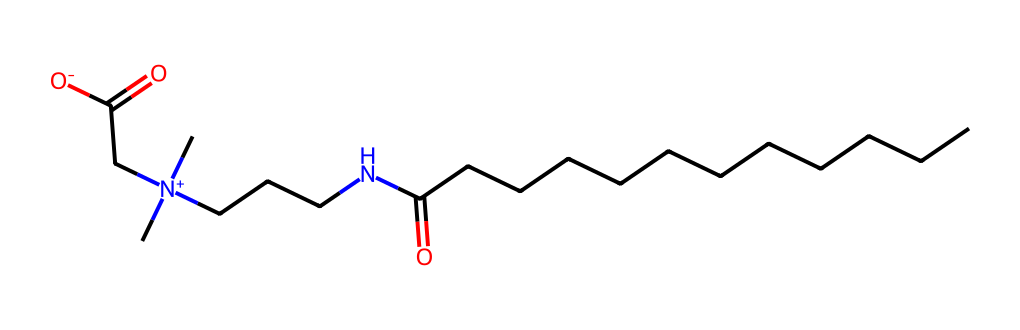What is the name of this chemical? The chemical structure given has characteristics of a surfactant, specifically surfactants derived from fatty acids. The structure indicates the presence of a cocamidopropyl group, which is derived from coconut oil, leading to the name cocamidopropyl betaine.
Answer: cocamidopropyl betaine How many carbon atoms are in this molecule? The SMILES representation shows a long carbon chain along with several branches. By counting the carbon atoms in the structure, there are a total of 12 carbon atoms connected in the chain and branches.
Answer: 12 What type of functional groups are present in this molecule? The molecule includes an amine group (due to the nitrogen atom) and a carboxylic acid group (indicated by the -COOH at the end of the structure). Thus, it contains both an amine and a carboxylic acid as part of its functional groups.
Answer: amine and carboxylic acid Why is this surfactant considered mild? The presence of a betaine structure, which is zwitterionic and has both a positive and negative charge, contributes to the mildness of the surfactant. This makes it non-irritating and suitable for sensitive skin, including that of teenagers.
Answer: zwitterionic structure What is the role of the nitrogen in this molecule? The nitrogen in cocamidopropyl betaine is part of the quaternary ammonium structure, contributing to its surfactant properties. It helps to lower the surface tension of water, allowing for better spreadability and cleansing properties.
Answer: surfactant properties Does the molecule have any charged regions? Yes, the nitrogen has a positive charge due to being a quaternary ammonium ion, and there is a corresponding negative charge from the carboxylate ion, indicating the presence of charged regions in the molecule.
Answer: Yes, charged regions 